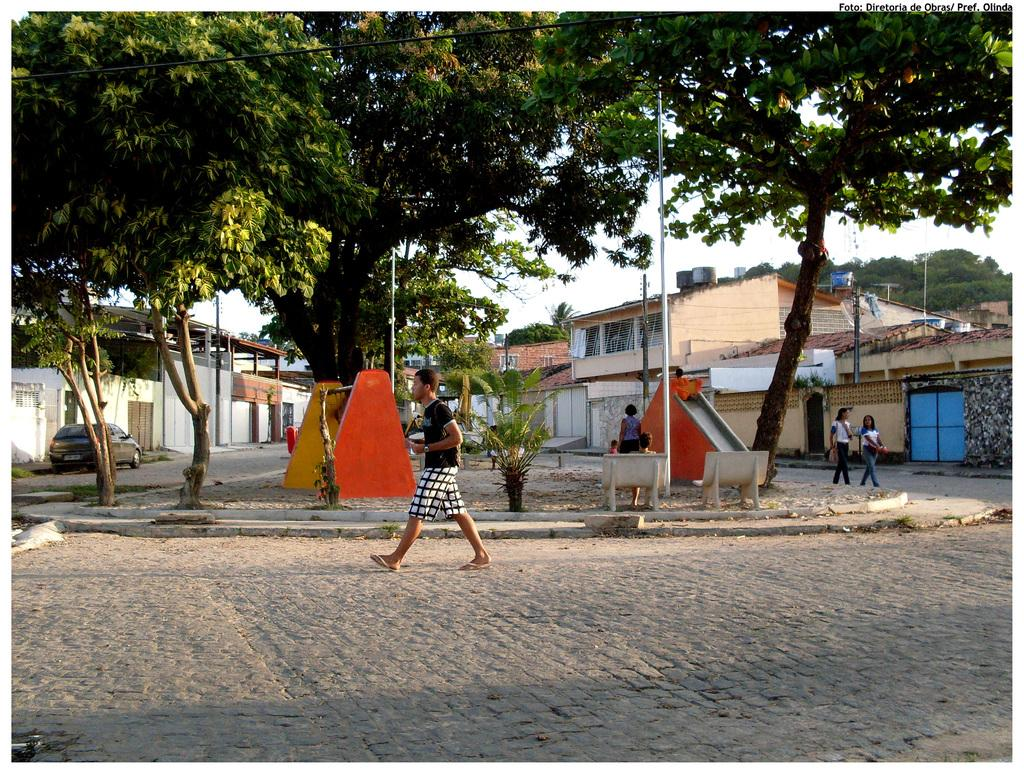What are the people in the image doing? The people in the image are walking on the ground. What can be seen in the background of the image? In the background of the image, there are trees, buildings, poles, the sky, a vehicle, and other unspecified objects. Can you describe the environment in the image? The environment in the image includes people walking on the ground, surrounded by trees, buildings, and other objects in the background. What type of butter is being used by the baby in the image? There is no baby or butter present in the image. Can you provide an example of an object that is not visible in the image? It is impossible to provide an example of an object that is not visible in the image, as we cannot see what is not present. 